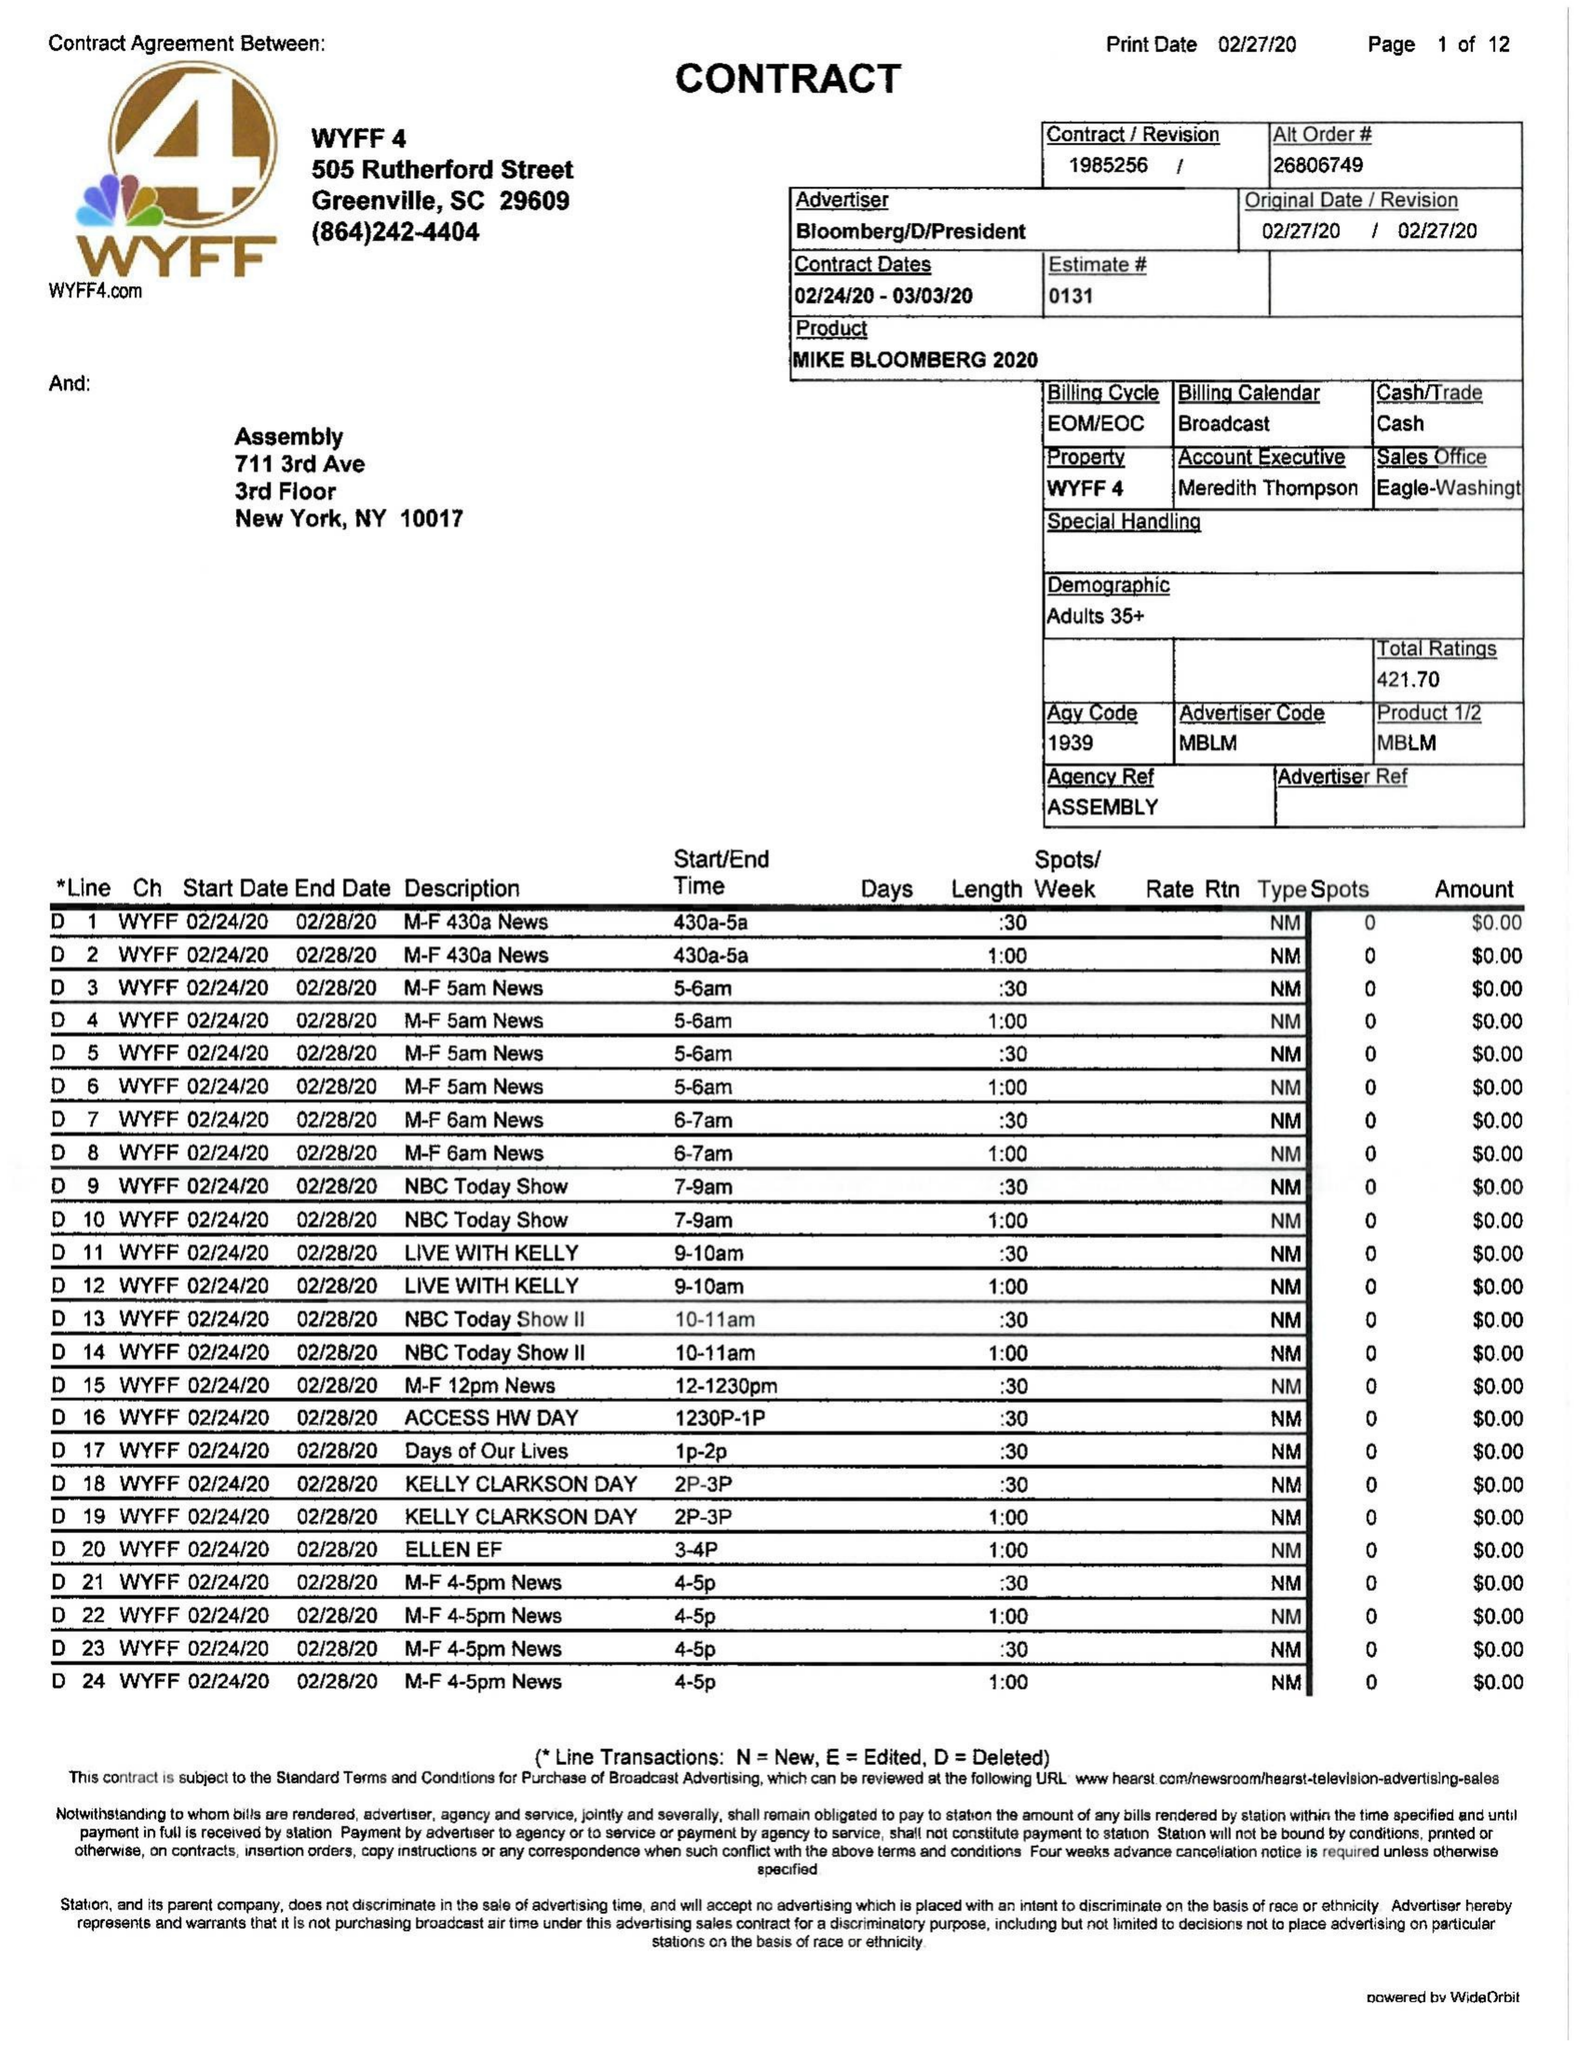What is the value for the flight_to?
Answer the question using a single word or phrase. 03/03/20 